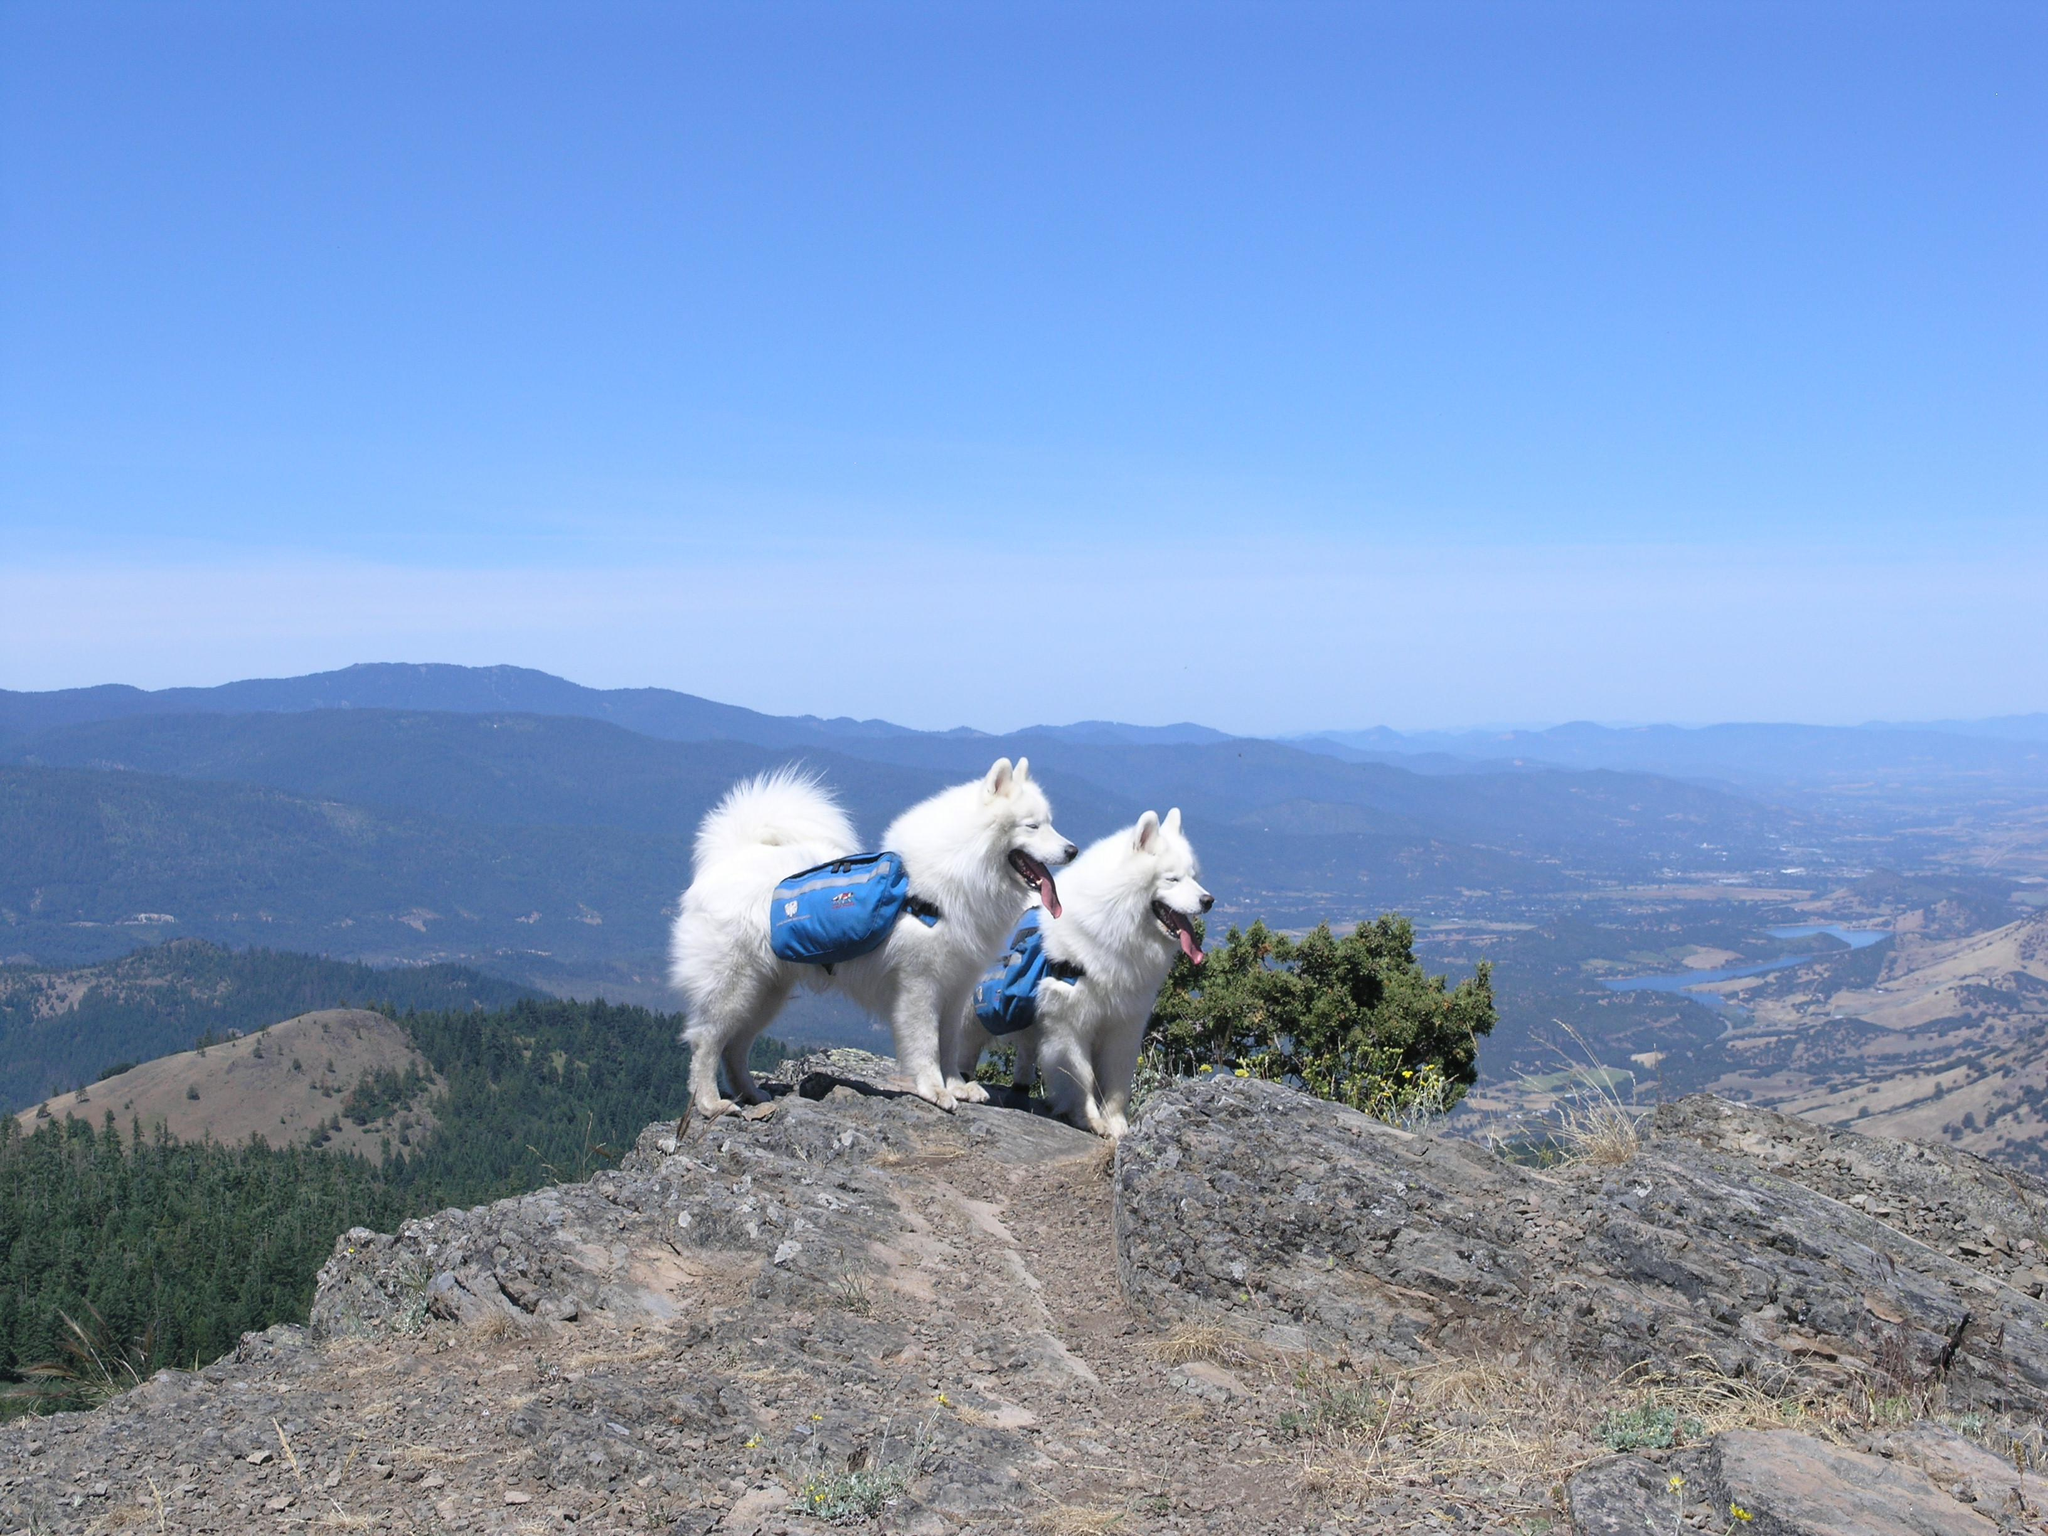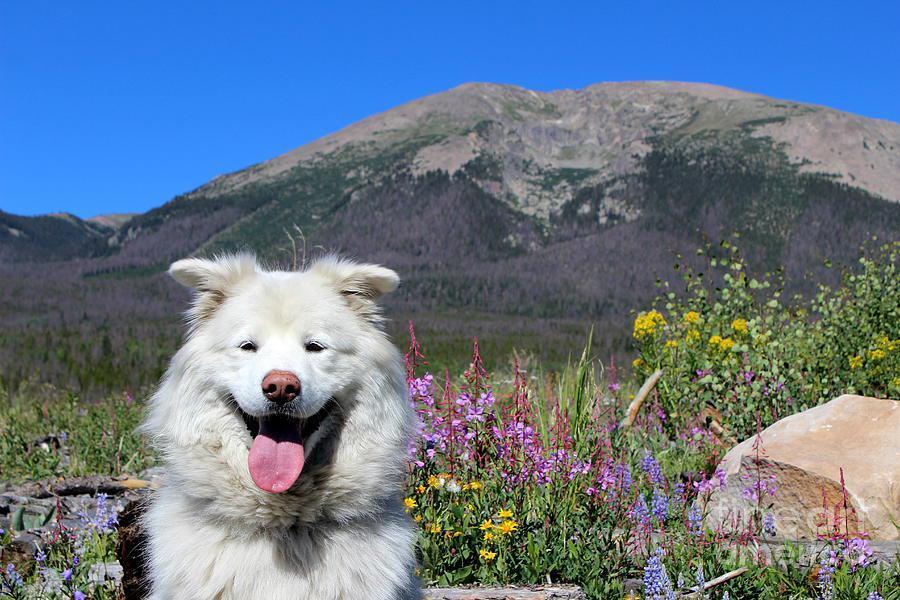The first image is the image on the left, the second image is the image on the right. Assess this claim about the two images: "There are three dogs in the image pair.". Correct or not? Answer yes or no. Yes. The first image is the image on the left, the second image is the image on the right. For the images displayed, is the sentence "Two white dogs wearing matching packs are side-by-side on an overlook, with hilly scenery in the background." factually correct? Answer yes or no. Yes. 